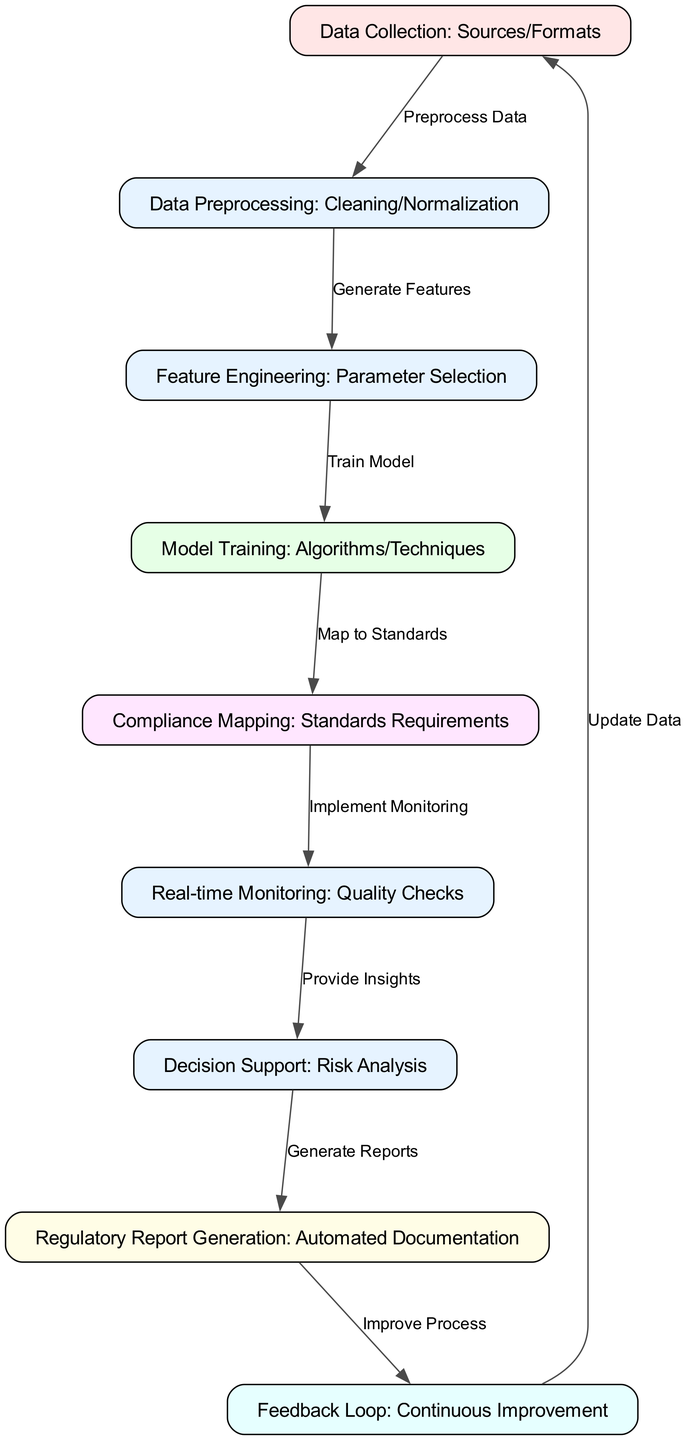What is the first step in the diagram? The diagram indicates that the first step is "Data Collection: Sources/Formats," as it is the starting node from which all other processes emanate.
Answer: Data Collection: Sources/Formats How many nodes are present in the diagram? By counting each distinct rectangular node, we find there are a total of 9 nodes represented in the diagram.
Answer: 9 What is the relationship between data preprocessing and feature engineering? The diagram shows an edge labeled "Generate Features" connecting "Data Preprocessing: Cleaning/Normalization" to "Feature Engineering: Parameter Selection," indicating that feature engineering follows preprocessing.
Answer: Generate Features Which node generates reports in the diagram? The node dedicated to the generation of reports is labeled "Regulatory Report Generation: Automated Documentation," marking its specific function within the workflow.
Answer: Regulatory Report Generation: Automated Documentation What flow follows compliance mapping? The next node after "Compliance Mapping: Standards Requirements" is "Real-time Monitoring: Quality Checks," indicating this is the subsequent process in the workflow after compliance mapping.
Answer: Real-time Monitoring: Quality Checks What does the feedback loop help improve? The feedback loop is labeled "Feedback Loop: Continuous Improvement," indicating its role in enhancing and refining the overall process based on previous outputs.
Answer: Continuous Improvement How many edges are in the diagram? By examining the connections between nodes, we find there are a total of 8 edges illustrated in the diagram.
Answer: 8 What does the decision support node provide? According to the diagram, the node "Decision Support: Risk Analysis" provides insights, which help in decision-making processes based on data gathered and analyzed earlier.
Answer: Provide Insights What happens after generating reports? After "Regulatory Report Generation: Automated Documentation," the next step is tied to the "Feedback Loop: Continuous Improvement," which signifies the iterative process of refining overall compliance strategies.
Answer: Improve Process 